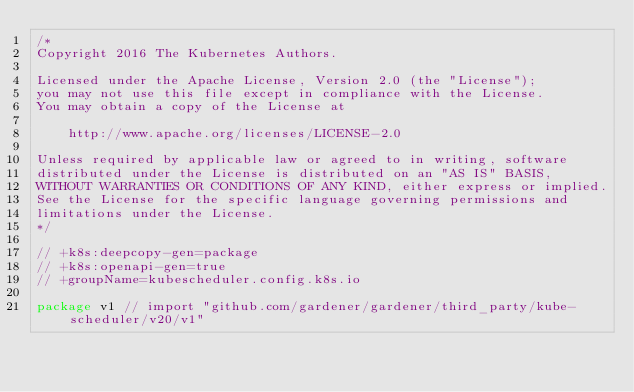Convert code to text. <code><loc_0><loc_0><loc_500><loc_500><_Go_>/*
Copyright 2016 The Kubernetes Authors.

Licensed under the Apache License, Version 2.0 (the "License");
you may not use this file except in compliance with the License.
You may obtain a copy of the License at

    http://www.apache.org/licenses/LICENSE-2.0

Unless required by applicable law or agreed to in writing, software
distributed under the License is distributed on an "AS IS" BASIS,
WITHOUT WARRANTIES OR CONDITIONS OF ANY KIND, either express or implied.
See the License for the specific language governing permissions and
limitations under the License.
*/

// +k8s:deepcopy-gen=package
// +k8s:openapi-gen=true
// +groupName=kubescheduler.config.k8s.io

package v1 // import "github.com/gardener/gardener/third_party/kube-scheduler/v20/v1"
</code> 